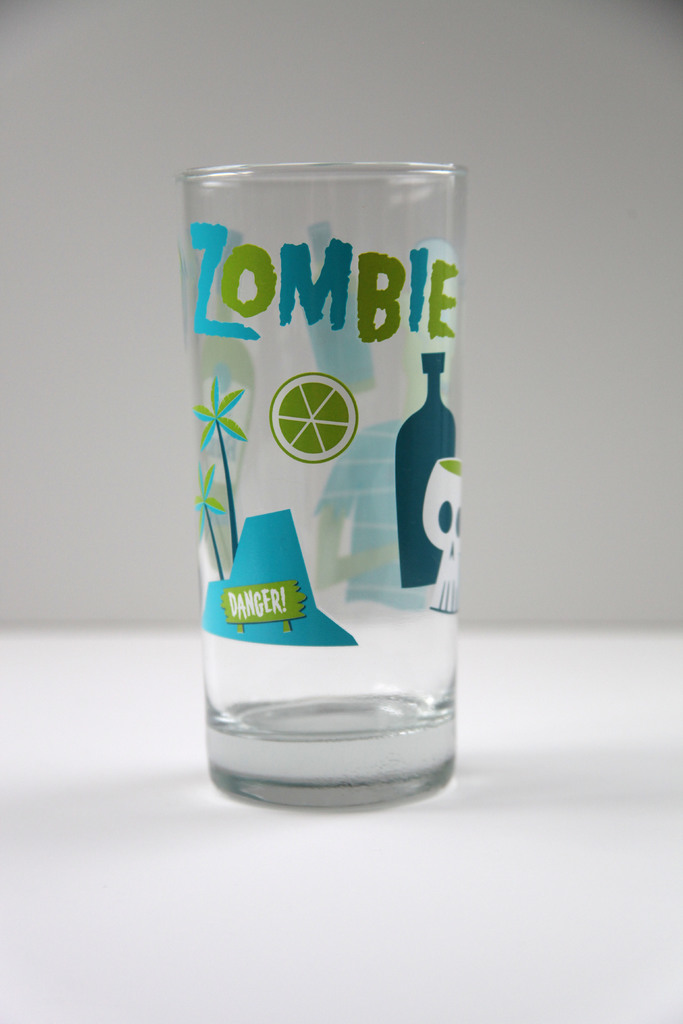How might this glass be used in a themed event or party? This glass would be perfect for a beach or Tiki-themed party, serving as a unique vessel for tropical cocktails. The fun and quirky design could enhance the exotic atmosphere, making it a hit among guests enjoying summer festivities. 